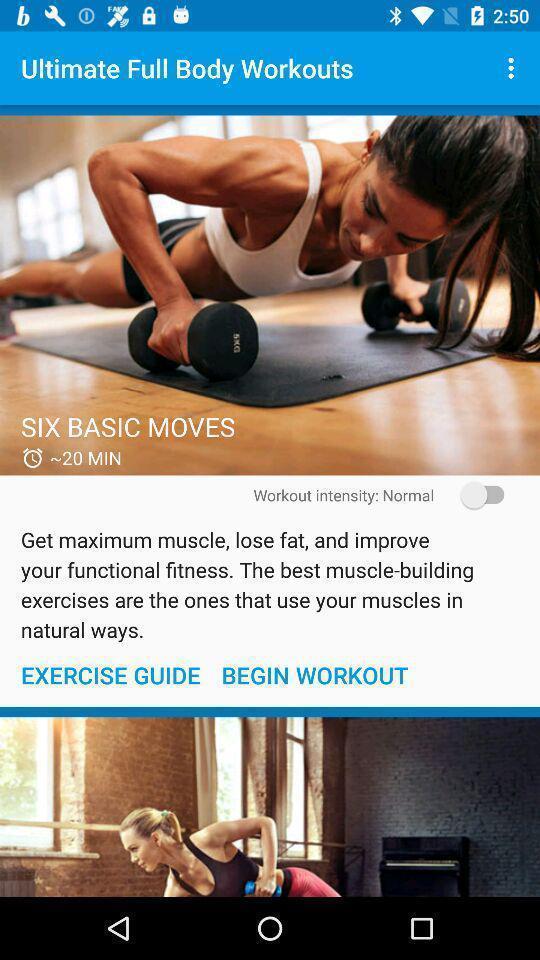Summarize the main components in this picture. Screen shows articles on workouts in a fitness app. 